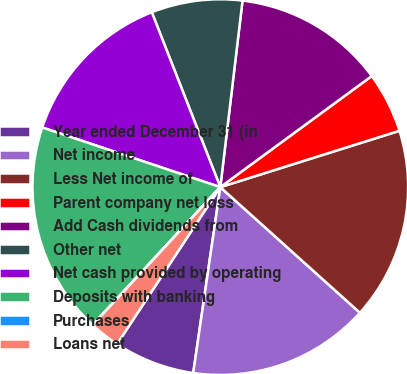Convert chart. <chart><loc_0><loc_0><loc_500><loc_500><pie_chart><fcel>Year ended December 31 (in<fcel>Net income<fcel>Less Net income of<fcel>Parent company net loss<fcel>Add Cash dividends from<fcel>Other net<fcel>Net cash provided by operating<fcel>Deposits with banking<fcel>Purchases<fcel>Loans net<nl><fcel>6.96%<fcel>15.64%<fcel>16.51%<fcel>5.22%<fcel>13.04%<fcel>7.83%<fcel>13.91%<fcel>18.25%<fcel>0.01%<fcel>2.62%<nl></chart> 